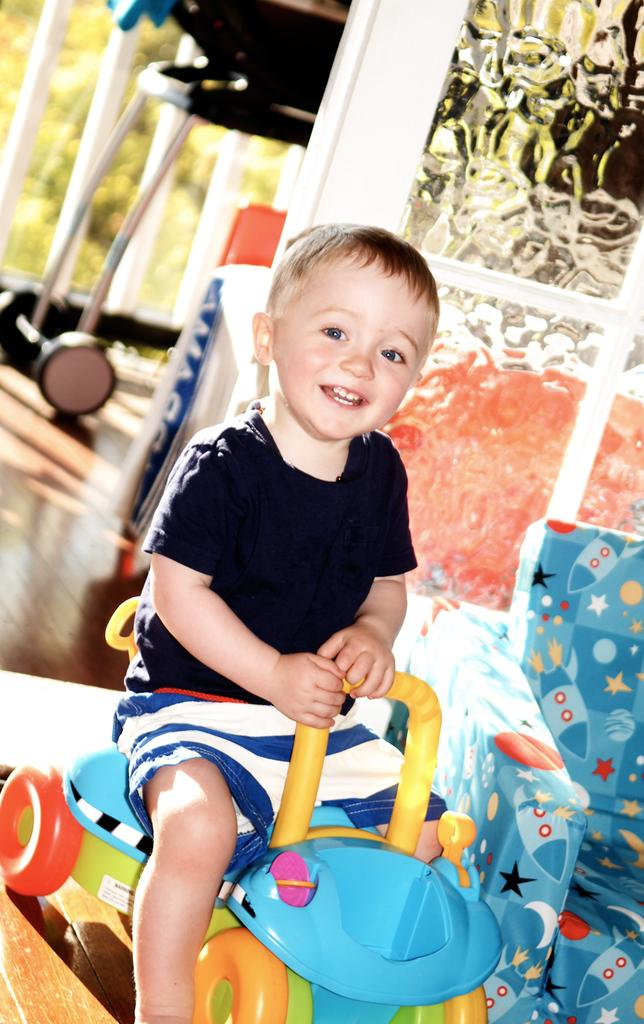What is the main subject of the image? There is a child in the image. What is the child doing in the image? The child is sitting on a toy. What type of furniture is on the right side of the image? There is a sofa chair on the right side of the image. What can be seen in the background of the image? There is a wall in the background of the image, and the background appears blurry. What grade did the child receive on their recent test in the image? There is no information about a test or grade in the image. Can you tell me how high the child is flying in the image? There is no indication of the child flying in the image; they are sitting on a toy. 